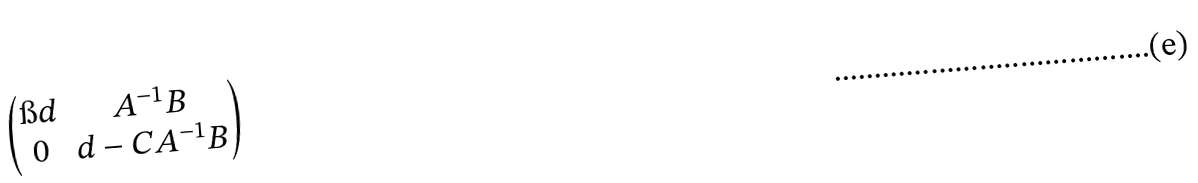Convert formula to latex. <formula><loc_0><loc_0><loc_500><loc_500>\begin{pmatrix} \i d & A ^ { - 1 } B \\ 0 & d - C A ^ { - 1 } B \end{pmatrix}</formula> 